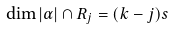<formula> <loc_0><loc_0><loc_500><loc_500>\dim | \alpha | \cap R _ { j } = ( k - j ) s</formula> 